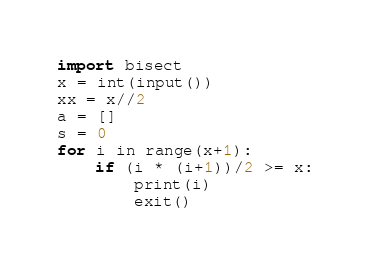Convert code to text. <code><loc_0><loc_0><loc_500><loc_500><_Python_>import bisect
x = int(input())
xx = x//2
a = []
s = 0
for i in range(x+1):
	if (i * (i+1))/2 >= x:
		print(i)
		exit()</code> 